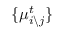Convert formula to latex. <formula><loc_0><loc_0><loc_500><loc_500>\{ \mu _ { i \ j } ^ { t } \}</formula> 